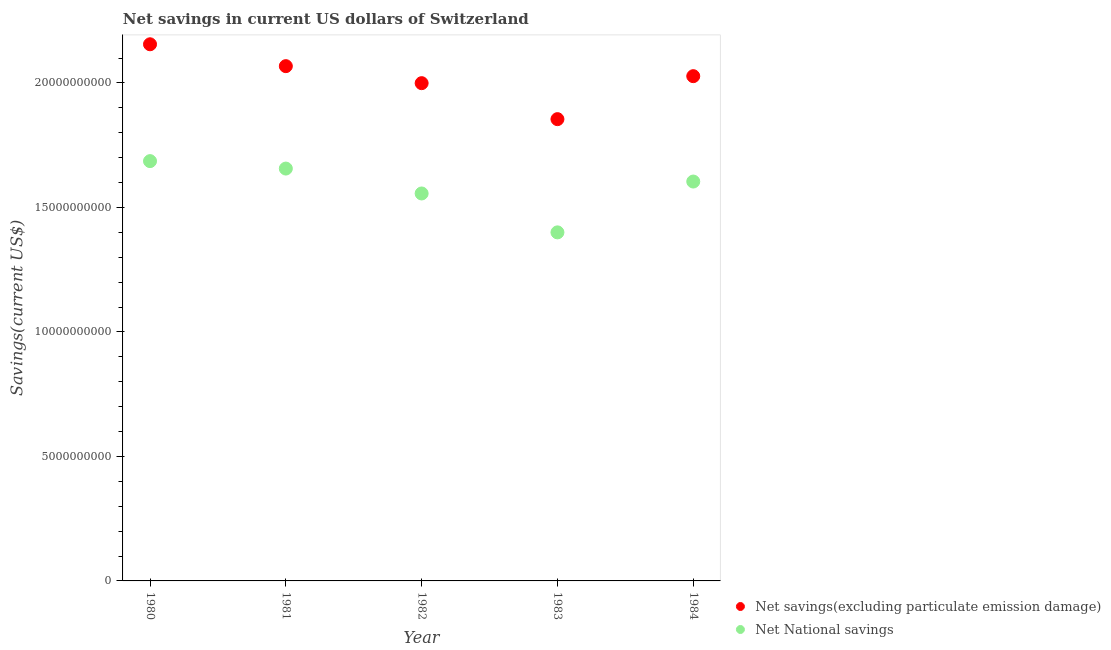Is the number of dotlines equal to the number of legend labels?
Your answer should be very brief. Yes. What is the net national savings in 1983?
Keep it short and to the point. 1.40e+1. Across all years, what is the maximum net national savings?
Provide a succinct answer. 1.69e+1. Across all years, what is the minimum net savings(excluding particulate emission damage)?
Make the answer very short. 1.85e+1. What is the total net savings(excluding particulate emission damage) in the graph?
Provide a succinct answer. 1.01e+11. What is the difference between the net savings(excluding particulate emission damage) in 1981 and that in 1983?
Ensure brevity in your answer.  2.13e+09. What is the difference between the net savings(excluding particulate emission damage) in 1981 and the net national savings in 1984?
Provide a succinct answer. 4.63e+09. What is the average net savings(excluding particulate emission damage) per year?
Offer a very short reply. 2.02e+1. In the year 1984, what is the difference between the net national savings and net savings(excluding particulate emission damage)?
Offer a very short reply. -4.23e+09. In how many years, is the net savings(excluding particulate emission damage) greater than 1000000000 US$?
Offer a terse response. 5. What is the ratio of the net savings(excluding particulate emission damage) in 1980 to that in 1981?
Ensure brevity in your answer.  1.04. Is the difference between the net national savings in 1980 and 1982 greater than the difference between the net savings(excluding particulate emission damage) in 1980 and 1982?
Keep it short and to the point. No. What is the difference between the highest and the second highest net savings(excluding particulate emission damage)?
Your response must be concise. 8.78e+08. What is the difference between the highest and the lowest net savings(excluding particulate emission damage)?
Keep it short and to the point. 3.01e+09. In how many years, is the net national savings greater than the average net national savings taken over all years?
Your answer should be very brief. 3. Is the net savings(excluding particulate emission damage) strictly greater than the net national savings over the years?
Ensure brevity in your answer.  Yes. Is the net national savings strictly less than the net savings(excluding particulate emission damage) over the years?
Make the answer very short. Yes. Does the graph contain any zero values?
Offer a terse response. No. Does the graph contain grids?
Give a very brief answer. No. How many legend labels are there?
Provide a short and direct response. 2. How are the legend labels stacked?
Keep it short and to the point. Vertical. What is the title of the graph?
Offer a terse response. Net savings in current US dollars of Switzerland. What is the label or title of the Y-axis?
Your answer should be very brief. Savings(current US$). What is the Savings(current US$) in Net savings(excluding particulate emission damage) in 1980?
Give a very brief answer. 2.16e+1. What is the Savings(current US$) of Net National savings in 1980?
Offer a very short reply. 1.69e+1. What is the Savings(current US$) of Net savings(excluding particulate emission damage) in 1981?
Keep it short and to the point. 2.07e+1. What is the Savings(current US$) of Net National savings in 1981?
Give a very brief answer. 1.66e+1. What is the Savings(current US$) in Net savings(excluding particulate emission damage) in 1982?
Offer a terse response. 2.00e+1. What is the Savings(current US$) in Net National savings in 1982?
Offer a terse response. 1.56e+1. What is the Savings(current US$) of Net savings(excluding particulate emission damage) in 1983?
Provide a succinct answer. 1.85e+1. What is the Savings(current US$) of Net National savings in 1983?
Ensure brevity in your answer.  1.40e+1. What is the Savings(current US$) in Net savings(excluding particulate emission damage) in 1984?
Ensure brevity in your answer.  2.03e+1. What is the Savings(current US$) in Net National savings in 1984?
Provide a short and direct response. 1.60e+1. Across all years, what is the maximum Savings(current US$) in Net savings(excluding particulate emission damage)?
Ensure brevity in your answer.  2.16e+1. Across all years, what is the maximum Savings(current US$) in Net National savings?
Offer a very short reply. 1.69e+1. Across all years, what is the minimum Savings(current US$) of Net savings(excluding particulate emission damage)?
Provide a short and direct response. 1.85e+1. Across all years, what is the minimum Savings(current US$) of Net National savings?
Offer a terse response. 1.40e+1. What is the total Savings(current US$) in Net savings(excluding particulate emission damage) in the graph?
Provide a short and direct response. 1.01e+11. What is the total Savings(current US$) of Net National savings in the graph?
Your answer should be compact. 7.90e+1. What is the difference between the Savings(current US$) in Net savings(excluding particulate emission damage) in 1980 and that in 1981?
Offer a very short reply. 8.78e+08. What is the difference between the Savings(current US$) of Net National savings in 1980 and that in 1981?
Provide a succinct answer. 2.99e+08. What is the difference between the Savings(current US$) of Net savings(excluding particulate emission damage) in 1980 and that in 1982?
Keep it short and to the point. 1.56e+09. What is the difference between the Savings(current US$) in Net National savings in 1980 and that in 1982?
Your answer should be very brief. 1.30e+09. What is the difference between the Savings(current US$) of Net savings(excluding particulate emission damage) in 1980 and that in 1983?
Ensure brevity in your answer.  3.01e+09. What is the difference between the Savings(current US$) of Net National savings in 1980 and that in 1983?
Your answer should be compact. 2.86e+09. What is the difference between the Savings(current US$) of Net savings(excluding particulate emission damage) in 1980 and that in 1984?
Provide a short and direct response. 1.28e+09. What is the difference between the Savings(current US$) of Net National savings in 1980 and that in 1984?
Your answer should be very brief. 8.20e+08. What is the difference between the Savings(current US$) of Net savings(excluding particulate emission damage) in 1981 and that in 1982?
Offer a very short reply. 6.83e+08. What is the difference between the Savings(current US$) of Net National savings in 1981 and that in 1982?
Offer a terse response. 1.00e+09. What is the difference between the Savings(current US$) in Net savings(excluding particulate emission damage) in 1981 and that in 1983?
Give a very brief answer. 2.13e+09. What is the difference between the Savings(current US$) of Net National savings in 1981 and that in 1983?
Your answer should be very brief. 2.56e+09. What is the difference between the Savings(current US$) in Net savings(excluding particulate emission damage) in 1981 and that in 1984?
Offer a very short reply. 4.02e+08. What is the difference between the Savings(current US$) in Net National savings in 1981 and that in 1984?
Your answer should be compact. 5.21e+08. What is the difference between the Savings(current US$) in Net savings(excluding particulate emission damage) in 1982 and that in 1983?
Keep it short and to the point. 1.45e+09. What is the difference between the Savings(current US$) in Net National savings in 1982 and that in 1983?
Make the answer very short. 1.56e+09. What is the difference between the Savings(current US$) of Net savings(excluding particulate emission damage) in 1982 and that in 1984?
Your answer should be compact. -2.81e+08. What is the difference between the Savings(current US$) in Net National savings in 1982 and that in 1984?
Make the answer very short. -4.79e+08. What is the difference between the Savings(current US$) in Net savings(excluding particulate emission damage) in 1983 and that in 1984?
Your response must be concise. -1.73e+09. What is the difference between the Savings(current US$) in Net National savings in 1983 and that in 1984?
Provide a short and direct response. -2.04e+09. What is the difference between the Savings(current US$) in Net savings(excluding particulate emission damage) in 1980 and the Savings(current US$) in Net National savings in 1981?
Your response must be concise. 4.99e+09. What is the difference between the Savings(current US$) of Net savings(excluding particulate emission damage) in 1980 and the Savings(current US$) of Net National savings in 1982?
Offer a very short reply. 5.99e+09. What is the difference between the Savings(current US$) in Net savings(excluding particulate emission damage) in 1980 and the Savings(current US$) in Net National savings in 1983?
Ensure brevity in your answer.  7.55e+09. What is the difference between the Savings(current US$) of Net savings(excluding particulate emission damage) in 1980 and the Savings(current US$) of Net National savings in 1984?
Provide a short and direct response. 5.51e+09. What is the difference between the Savings(current US$) of Net savings(excluding particulate emission damage) in 1981 and the Savings(current US$) of Net National savings in 1982?
Provide a short and direct response. 5.11e+09. What is the difference between the Savings(current US$) of Net savings(excluding particulate emission damage) in 1981 and the Savings(current US$) of Net National savings in 1983?
Offer a terse response. 6.68e+09. What is the difference between the Savings(current US$) in Net savings(excluding particulate emission damage) in 1981 and the Savings(current US$) in Net National savings in 1984?
Offer a terse response. 4.63e+09. What is the difference between the Savings(current US$) of Net savings(excluding particulate emission damage) in 1982 and the Savings(current US$) of Net National savings in 1983?
Keep it short and to the point. 5.99e+09. What is the difference between the Savings(current US$) of Net savings(excluding particulate emission damage) in 1982 and the Savings(current US$) of Net National savings in 1984?
Make the answer very short. 3.95e+09. What is the difference between the Savings(current US$) in Net savings(excluding particulate emission damage) in 1983 and the Savings(current US$) in Net National savings in 1984?
Your answer should be very brief. 2.51e+09. What is the average Savings(current US$) of Net savings(excluding particulate emission damage) per year?
Ensure brevity in your answer.  2.02e+1. What is the average Savings(current US$) of Net National savings per year?
Provide a short and direct response. 1.58e+1. In the year 1980, what is the difference between the Savings(current US$) of Net savings(excluding particulate emission damage) and Savings(current US$) of Net National savings?
Give a very brief answer. 4.69e+09. In the year 1981, what is the difference between the Savings(current US$) in Net savings(excluding particulate emission damage) and Savings(current US$) in Net National savings?
Your response must be concise. 4.11e+09. In the year 1982, what is the difference between the Savings(current US$) of Net savings(excluding particulate emission damage) and Savings(current US$) of Net National savings?
Provide a succinct answer. 4.43e+09. In the year 1983, what is the difference between the Savings(current US$) in Net savings(excluding particulate emission damage) and Savings(current US$) in Net National savings?
Provide a short and direct response. 4.55e+09. In the year 1984, what is the difference between the Savings(current US$) in Net savings(excluding particulate emission damage) and Savings(current US$) in Net National savings?
Your response must be concise. 4.23e+09. What is the ratio of the Savings(current US$) in Net savings(excluding particulate emission damage) in 1980 to that in 1981?
Provide a short and direct response. 1.04. What is the ratio of the Savings(current US$) in Net National savings in 1980 to that in 1981?
Your answer should be compact. 1.02. What is the ratio of the Savings(current US$) in Net savings(excluding particulate emission damage) in 1980 to that in 1982?
Give a very brief answer. 1.08. What is the ratio of the Savings(current US$) of Net National savings in 1980 to that in 1982?
Provide a succinct answer. 1.08. What is the ratio of the Savings(current US$) of Net savings(excluding particulate emission damage) in 1980 to that in 1983?
Your answer should be compact. 1.16. What is the ratio of the Savings(current US$) of Net National savings in 1980 to that in 1983?
Provide a succinct answer. 1.2. What is the ratio of the Savings(current US$) in Net savings(excluding particulate emission damage) in 1980 to that in 1984?
Provide a short and direct response. 1.06. What is the ratio of the Savings(current US$) of Net National savings in 1980 to that in 1984?
Ensure brevity in your answer.  1.05. What is the ratio of the Savings(current US$) of Net savings(excluding particulate emission damage) in 1981 to that in 1982?
Your answer should be very brief. 1.03. What is the ratio of the Savings(current US$) of Net National savings in 1981 to that in 1982?
Offer a terse response. 1.06. What is the ratio of the Savings(current US$) of Net savings(excluding particulate emission damage) in 1981 to that in 1983?
Offer a very short reply. 1.11. What is the ratio of the Savings(current US$) of Net National savings in 1981 to that in 1983?
Provide a short and direct response. 1.18. What is the ratio of the Savings(current US$) in Net savings(excluding particulate emission damage) in 1981 to that in 1984?
Your answer should be compact. 1.02. What is the ratio of the Savings(current US$) in Net National savings in 1981 to that in 1984?
Your answer should be very brief. 1.03. What is the ratio of the Savings(current US$) in Net savings(excluding particulate emission damage) in 1982 to that in 1983?
Provide a succinct answer. 1.08. What is the ratio of the Savings(current US$) of Net National savings in 1982 to that in 1983?
Your response must be concise. 1.11. What is the ratio of the Savings(current US$) in Net savings(excluding particulate emission damage) in 1982 to that in 1984?
Offer a very short reply. 0.99. What is the ratio of the Savings(current US$) in Net National savings in 1982 to that in 1984?
Offer a very short reply. 0.97. What is the ratio of the Savings(current US$) of Net savings(excluding particulate emission damage) in 1983 to that in 1984?
Keep it short and to the point. 0.91. What is the ratio of the Savings(current US$) of Net National savings in 1983 to that in 1984?
Offer a very short reply. 0.87. What is the difference between the highest and the second highest Savings(current US$) of Net savings(excluding particulate emission damage)?
Provide a short and direct response. 8.78e+08. What is the difference between the highest and the second highest Savings(current US$) in Net National savings?
Your response must be concise. 2.99e+08. What is the difference between the highest and the lowest Savings(current US$) of Net savings(excluding particulate emission damage)?
Your answer should be very brief. 3.01e+09. What is the difference between the highest and the lowest Savings(current US$) of Net National savings?
Make the answer very short. 2.86e+09. 